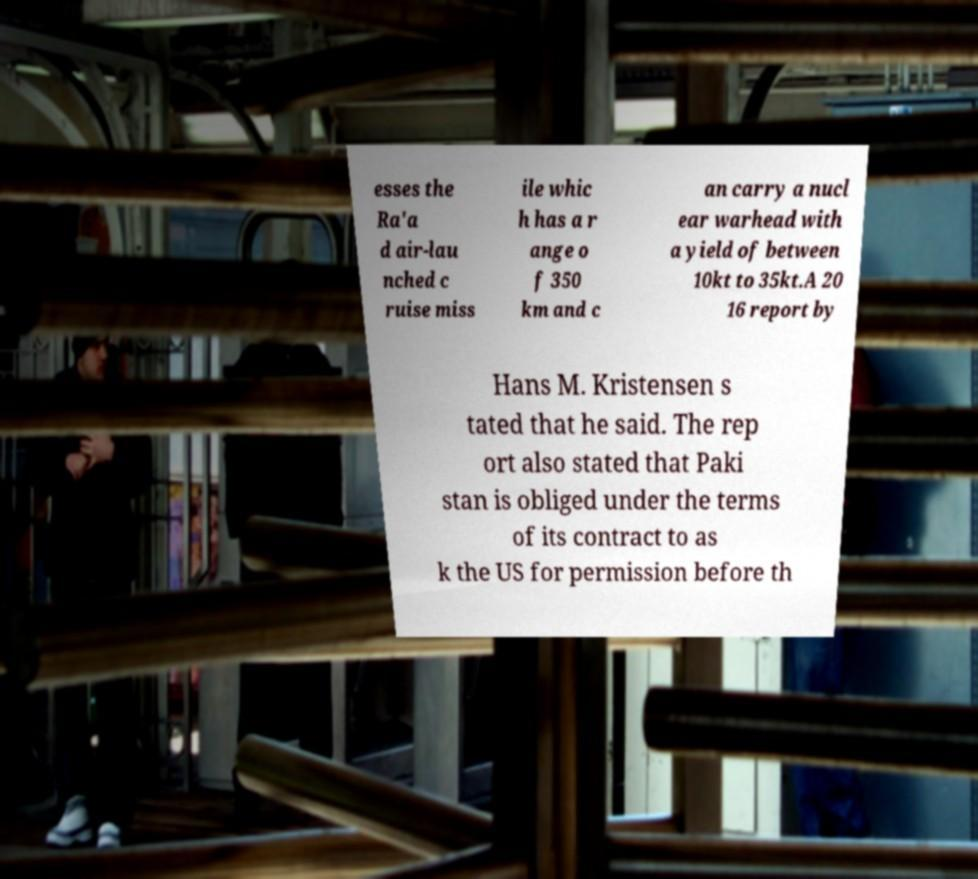Can you accurately transcribe the text from the provided image for me? esses the Ra'a d air-lau nched c ruise miss ile whic h has a r ange o f 350 km and c an carry a nucl ear warhead with a yield of between 10kt to 35kt.A 20 16 report by Hans M. Kristensen s tated that he said. The rep ort also stated that Paki stan is obliged under the terms of its contract to as k the US for permission before th 